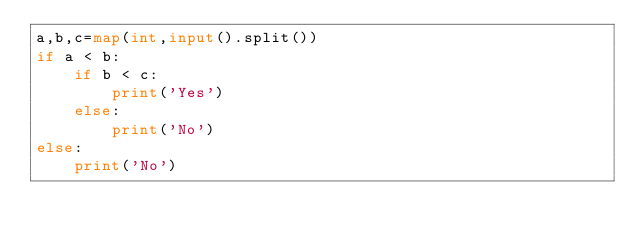Convert code to text. <code><loc_0><loc_0><loc_500><loc_500><_Python_>a,b,c=map(int,input().split())
if a < b:
    if b < c:
        print('Yes')
    else:
        print('No')
else:
    print('No')
</code> 